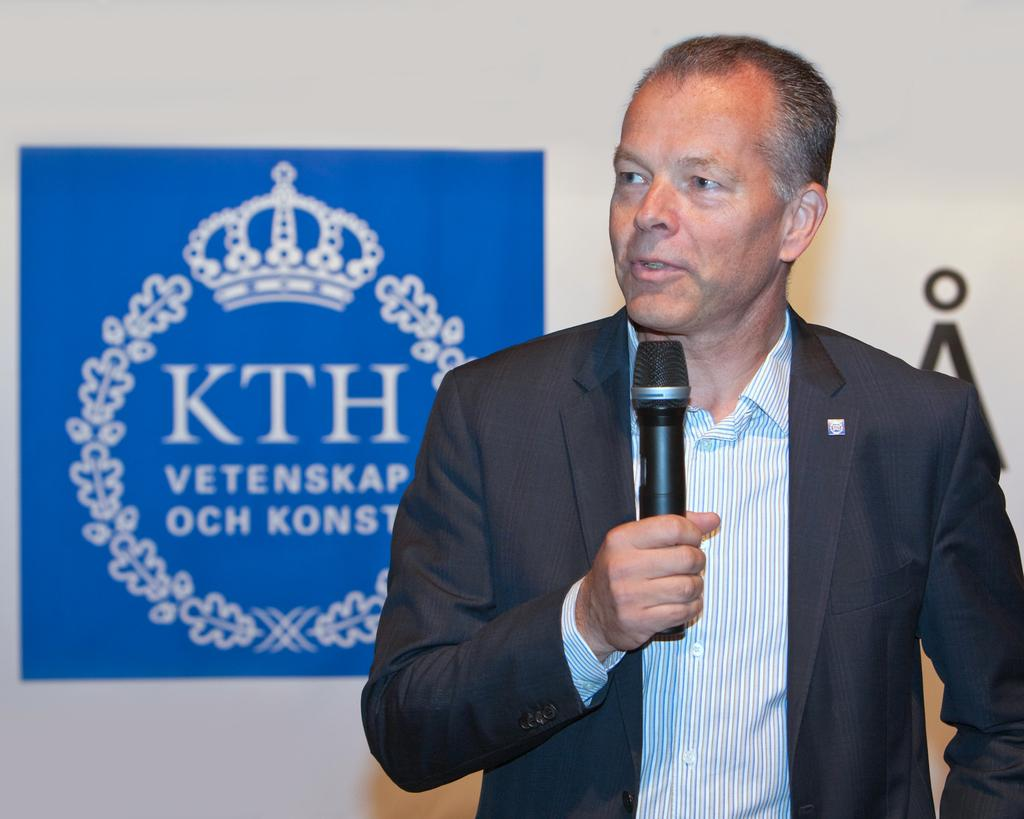What is the person in the image doing? The person is standing and speaking in the image. What is the person wearing? The person is wearing a suit. What object is the person holding in his hand? The person is holding a microphone in his hand. What can be seen on the white wall in the background? There is a blue banner on the white wall. What is on the blue banner? The blue banner has text or a design on it. How many cars are parked in front of the person in the image? There are no cars visible in the image. What type of cloud can be seen in the background of the image? There are no clouds visible in the image. 